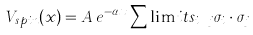Convert formula to latex. <formula><loc_0><loc_0><loc_500><loc_500>V _ { s p i n } ( x ) = A \, e ^ { - \alpha x } \sum \lim i t s _ { i { \neq } j } \sigma _ { i } \cdot \sigma _ { j }</formula> 